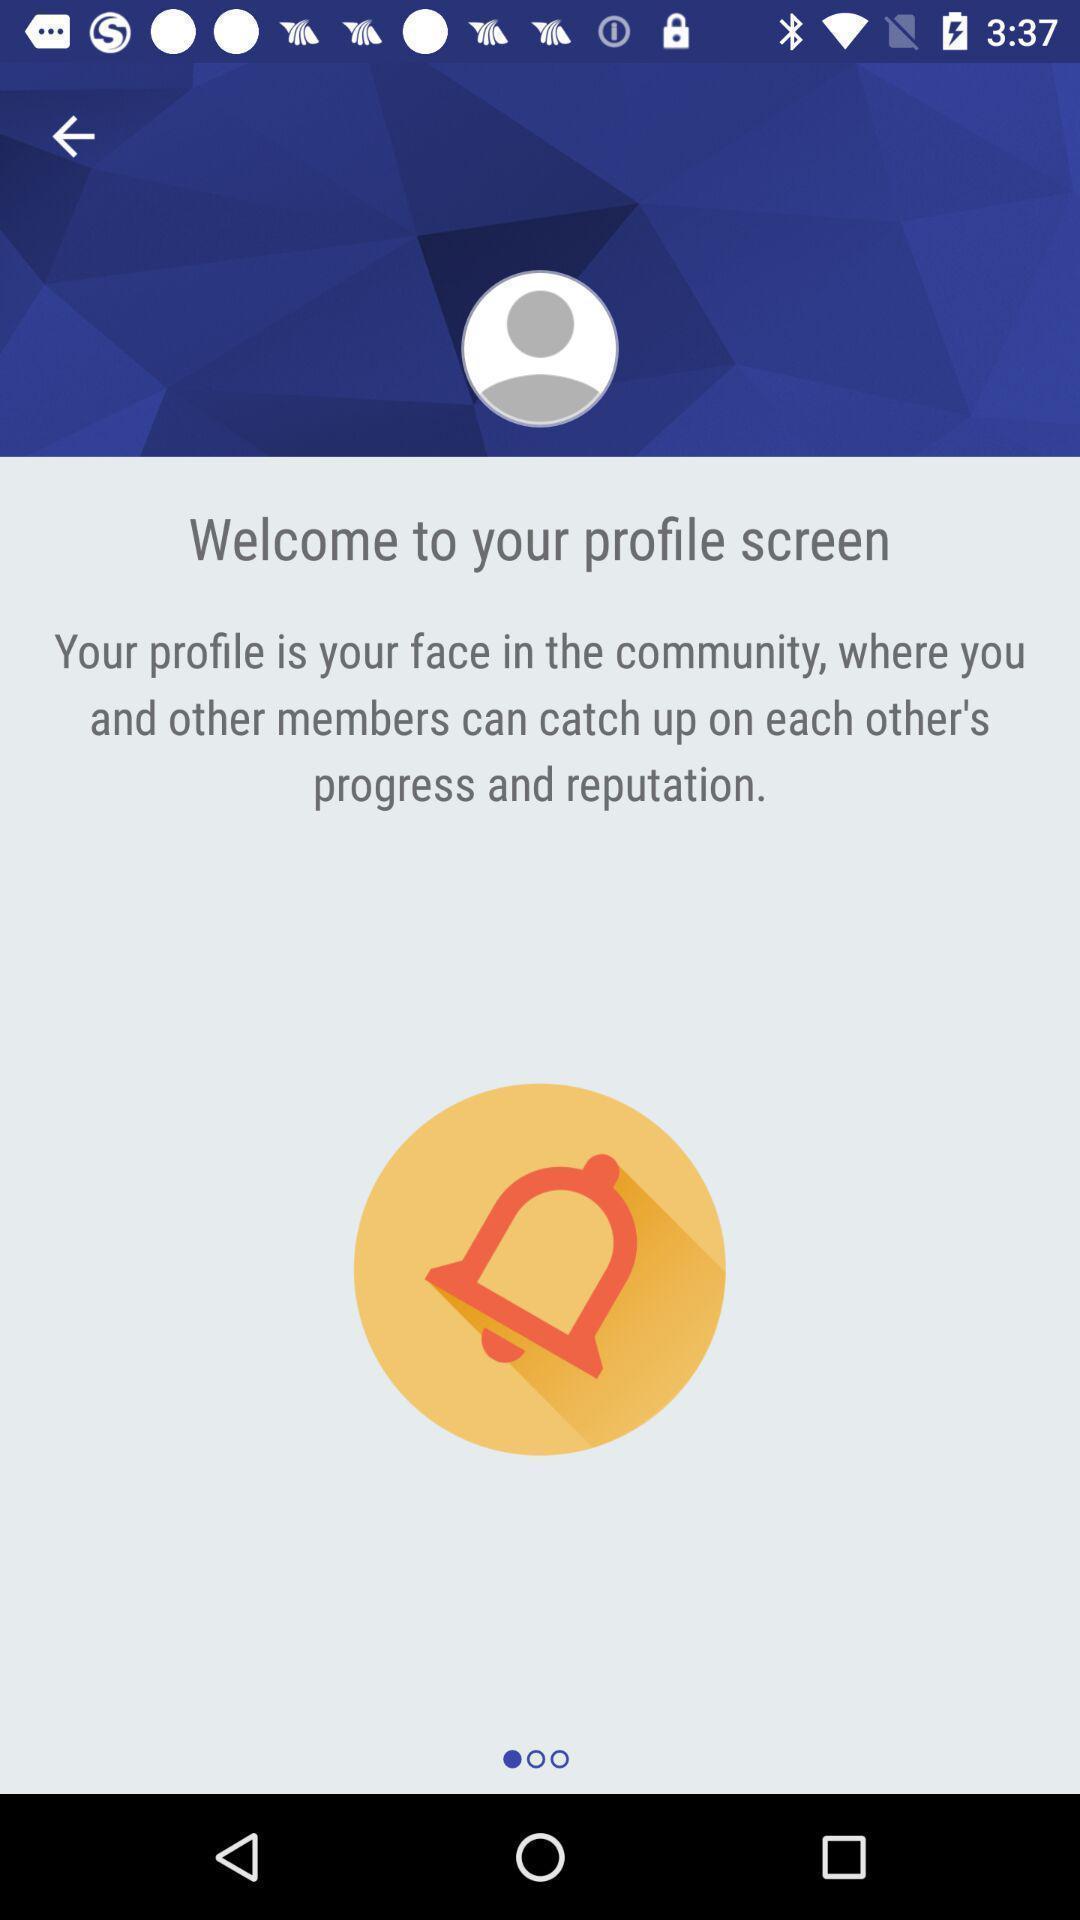Provide a textual representation of this image. Welcome page. 